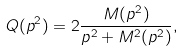<formula> <loc_0><loc_0><loc_500><loc_500>Q ( p ^ { 2 } ) = 2 \frac { M ( p ^ { 2 } ) } { p ^ { 2 } + M ^ { 2 } ( p ^ { 2 } ) } ,</formula> 